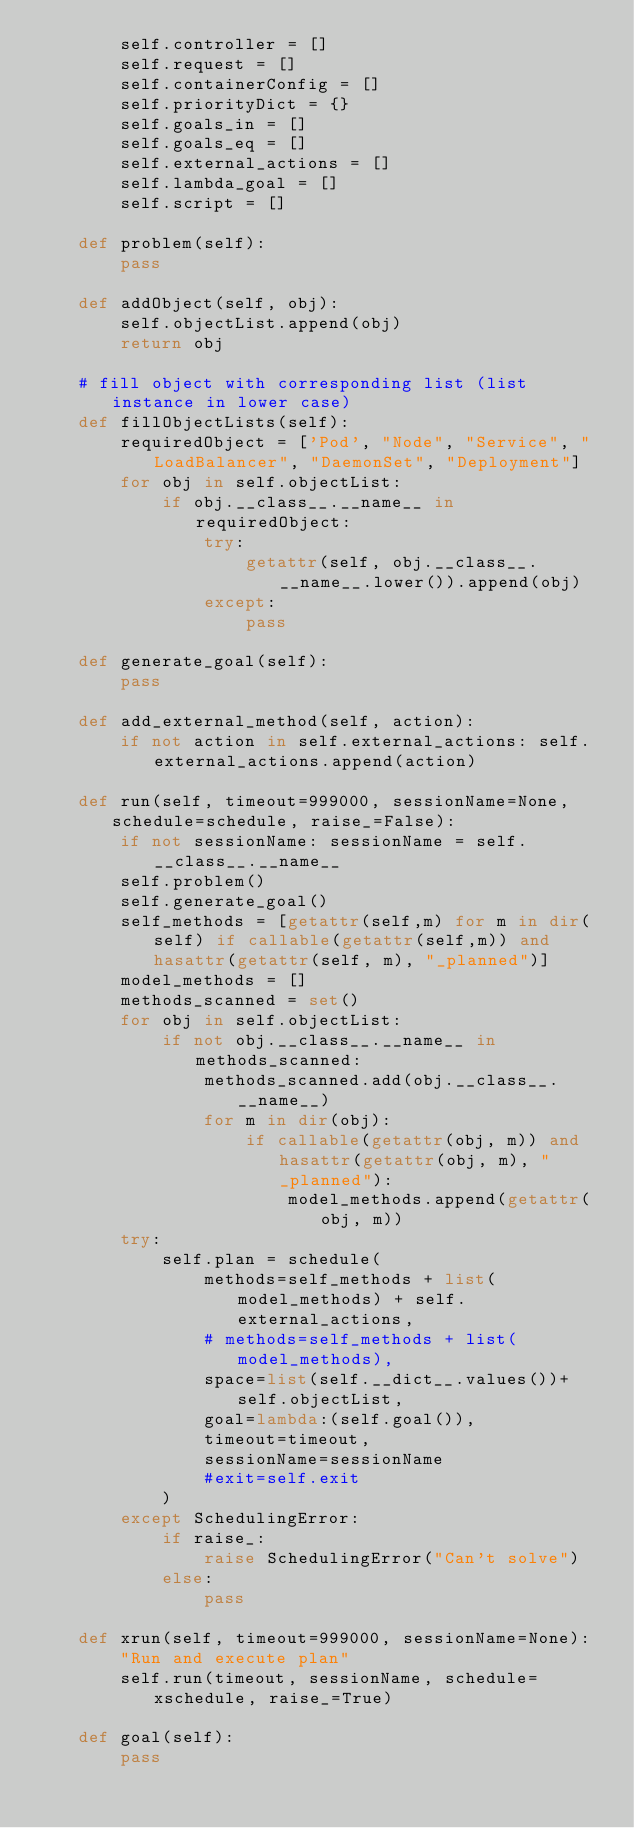Convert code to text. <code><loc_0><loc_0><loc_500><loc_500><_Python_>        self.controller = []
        self.request = []
        self.containerConfig = []
        self.priorityDict = {}
        self.goals_in = []
        self.goals_eq = []
        self.external_actions = []
        self.lambda_goal = []
        self.script = []
    
    def problem(self):
        pass
        
    def addObject(self, obj):
        self.objectList.append(obj)
        return obj

    # fill object with corresponding list (list instance in lower case)
    def fillObjectLists(self):
        requiredObject = ['Pod', "Node", "Service", "LoadBalancer", "DaemonSet", "Deployment"]
        for obj in self.objectList:
            if obj.__class__.__name__ in requiredObject:
                try:
                    getattr(self, obj.__class__.__name__.lower()).append(obj)
                except:
                    pass
            
    def generate_goal(self):
        pass

    def add_external_method(self, action):
        if not action in self.external_actions: self.external_actions.append(action)

    def run(self, timeout=999000, sessionName=None, schedule=schedule, raise_=False):
        if not sessionName: sessionName = self.__class__.__name__
        self.problem()
        self.generate_goal()
        self_methods = [getattr(self,m) for m in dir(self) if callable(getattr(self,m)) and hasattr(getattr(self, m), "_planned")]
        model_methods = []
        methods_scanned = set()
        for obj in self.objectList:
            if not obj.__class__.__name__ in methods_scanned:
                methods_scanned.add(obj.__class__.__name__)
                for m in dir(obj):
                    if callable(getattr(obj, m)) and hasattr(getattr(obj, m), "_planned"):
                        model_methods.append(getattr(obj, m))
        try:
            self.plan = schedule(
                methods=self_methods + list(model_methods) + self.external_actions, 
                # methods=self_methods + list(model_methods), 
                space=list(self.__dict__.values())+self.objectList,
                goal=lambda:(self.goal()),
                timeout=timeout,
                sessionName=sessionName
                #exit=self.exit
            )
        except SchedulingError:
            if raise_:
                raise SchedulingError("Can't solve")
            else:
                pass
    
    def xrun(self, timeout=999000, sessionName=None):
        "Run and execute plan"
        self.run(timeout, sessionName, schedule=xschedule, raise_=True)

    def goal(self):
        pass

    </code> 